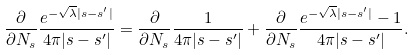Convert formula to latex. <formula><loc_0><loc_0><loc_500><loc_500>\frac { \partial } { \partial N _ { s } } \frac { e ^ { - \sqrt { \lambda } | s - s ^ { \prime } | } } { 4 \pi | s - s ^ { \prime } | } = \frac { \partial } { \partial N _ { s } } \frac { 1 } { 4 \pi | s - s ^ { \prime } | } + \frac { \partial } { \partial N _ { s } } \frac { e ^ { - \sqrt { \lambda } | s - s ^ { \prime } | } - 1 } { 4 \pi | s - s ^ { \prime } | } .</formula> 